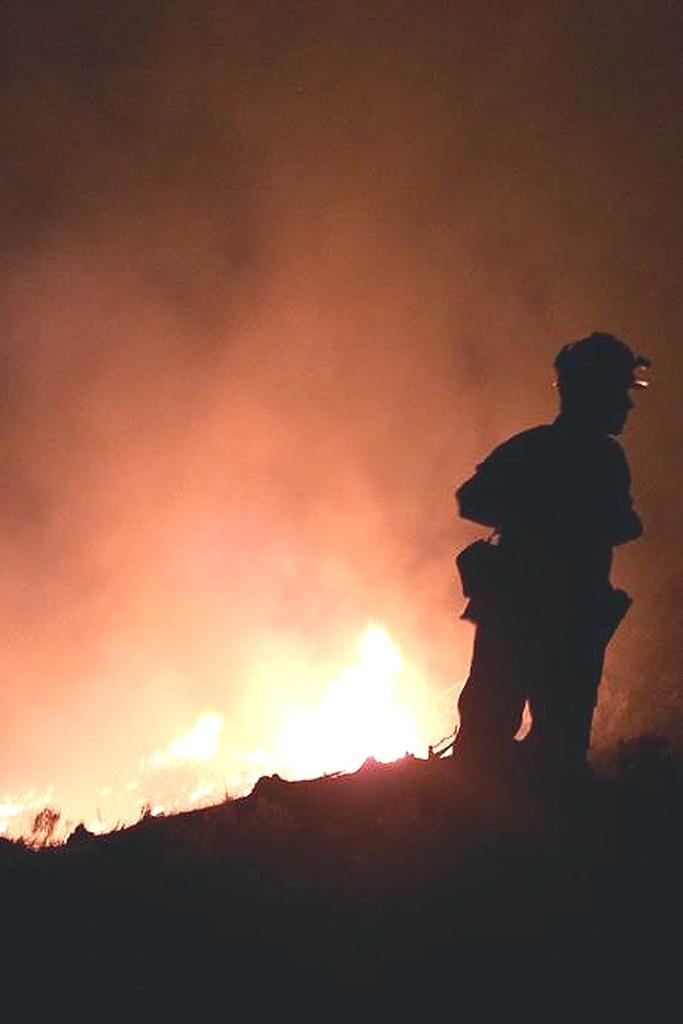What is the main subject of the image? There is a person standing in the image. What can be seen in the background or near the person? There is a flame and smoke visible in the image. What is the weight of the dog in the image? There is no dog present in the image, so we cannot determine its weight. 